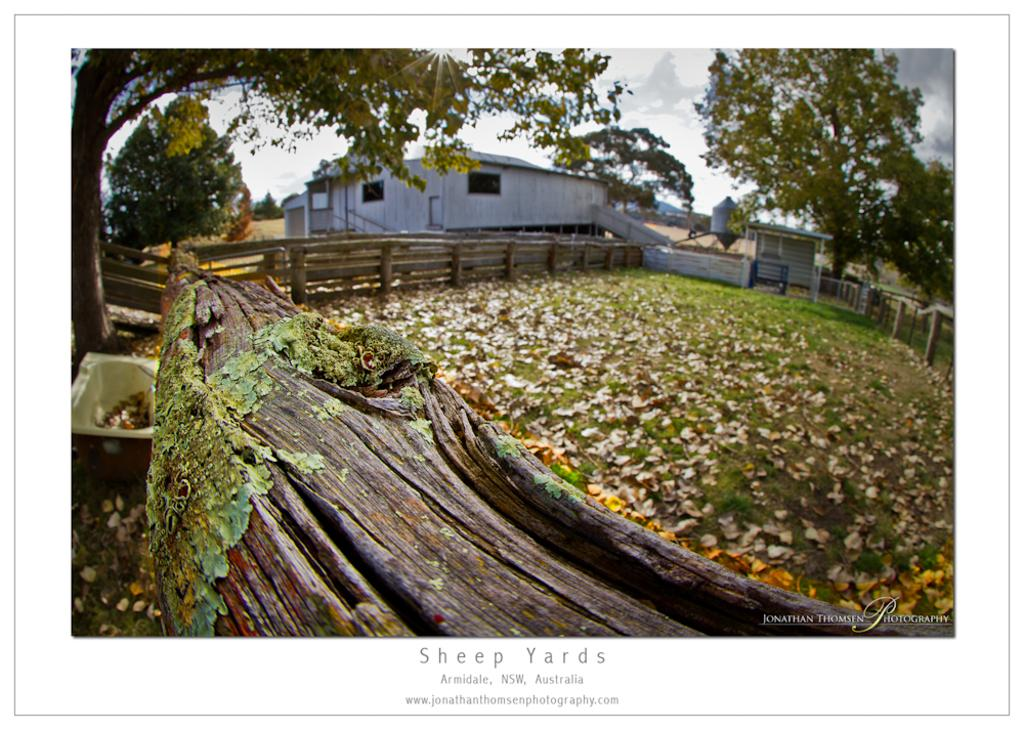What type of barrier surrounds the ground in the image? There is a wooden fence around the ground. What can be found on the ground in the image? Dried leaves are present on the ground. What is visible in the background of the image? There are trees and buildings in the background of the image. How many heads can be seen on the trees in the image? There are no heads visible on the trees in the image; only leaves and branches can be seen. What type of spark can be seen coming from the leaves on the ground? There is no spark present in the image; the leaves on the ground are dried and not producing any sparks. 